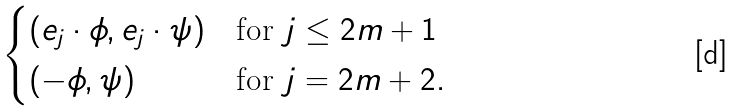Convert formula to latex. <formula><loc_0><loc_0><loc_500><loc_500>\begin{cases} ( e _ { j } \cdot \phi , e _ { j } \cdot \psi ) & \text {for $j\leq 2m+1$} \\ ( - \phi , \psi ) & \text {for $j=2m+2$} . \end{cases}</formula> 